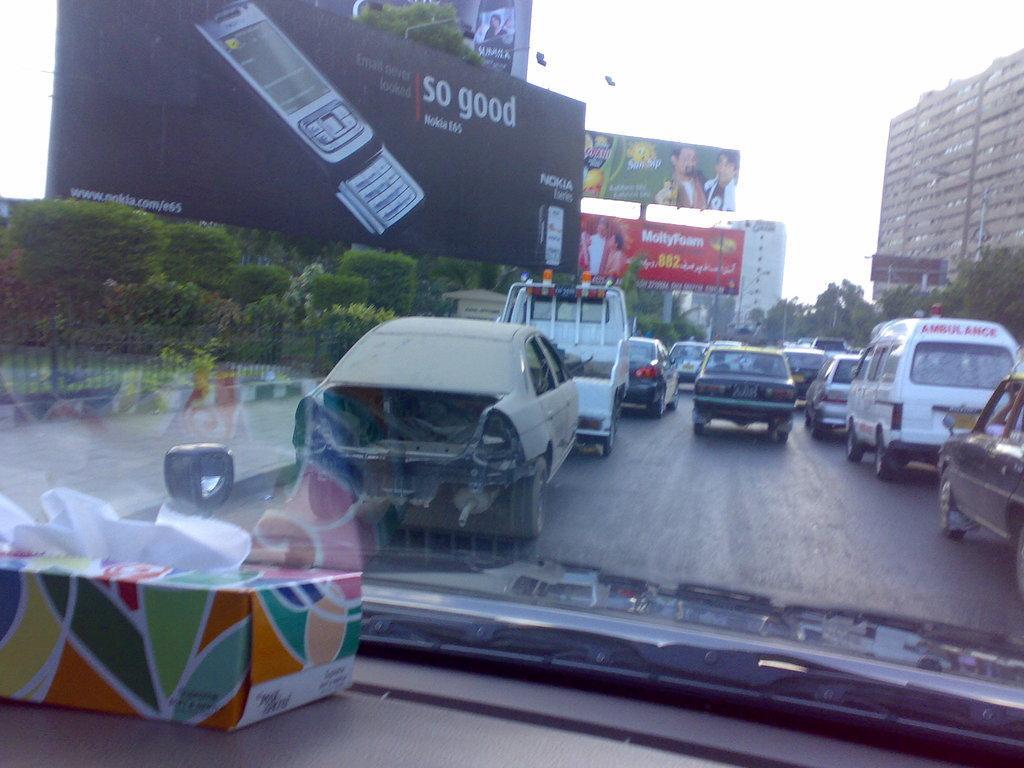Please provide a concise description of this image. In this image we can see a group of vehicles on the road. We can also see a fence, a group of plants, banners with some pictures and text on it, some poles, a signboard, lights, some buildings with windows and the sky. On the left side we can see a box which is placed beside the window of a car. 